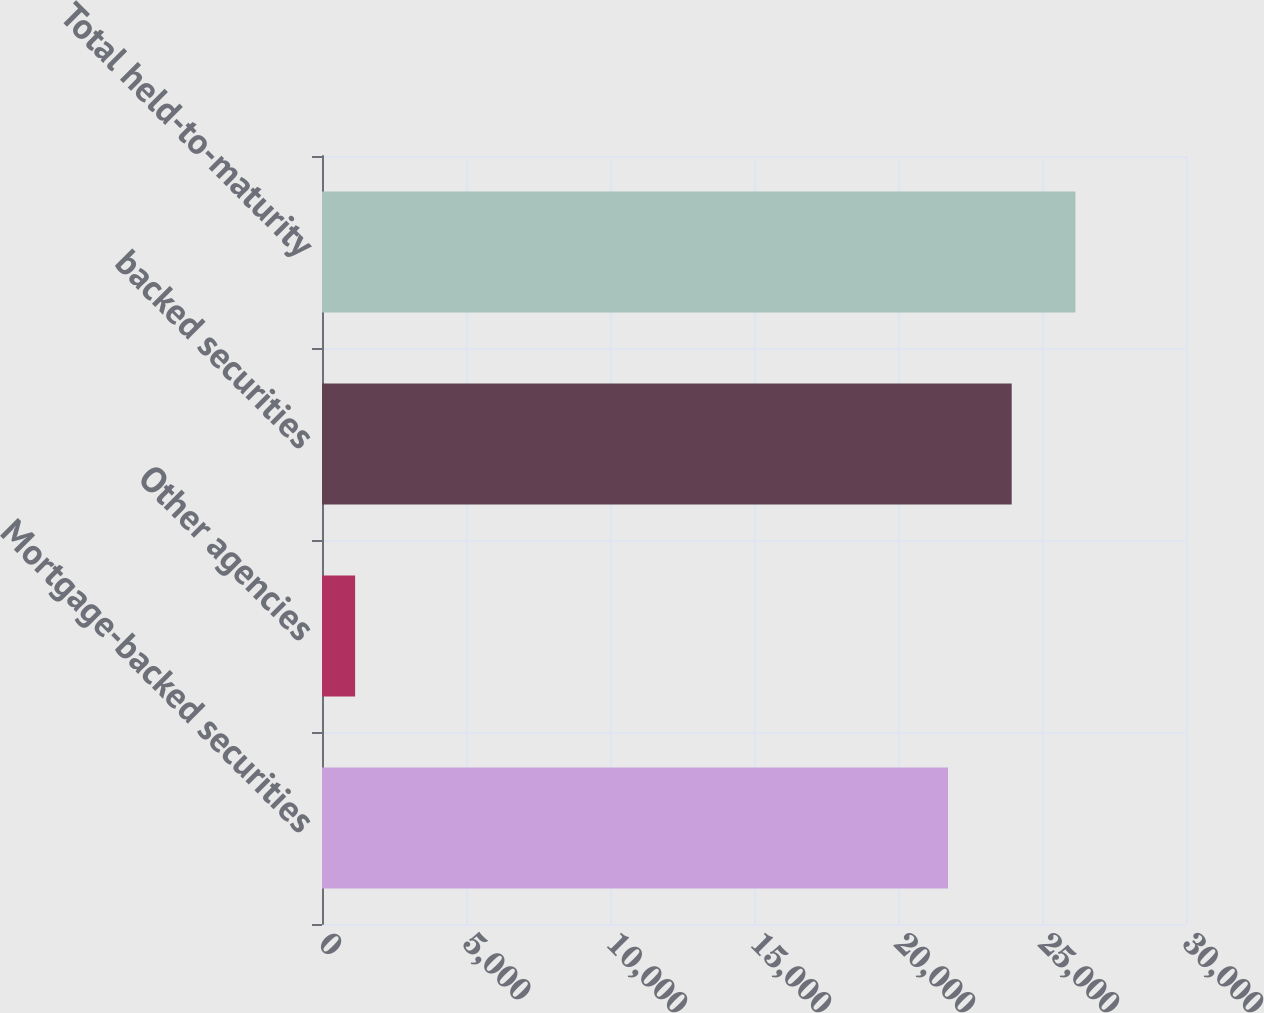<chart> <loc_0><loc_0><loc_500><loc_500><bar_chart><fcel>Mortgage-backed securities<fcel>Other agencies<fcel>backed securities<fcel>Total held-to-maturity<nl><fcel>21736<fcel>1150<fcel>23948.3<fcel>26160.6<nl></chart> 